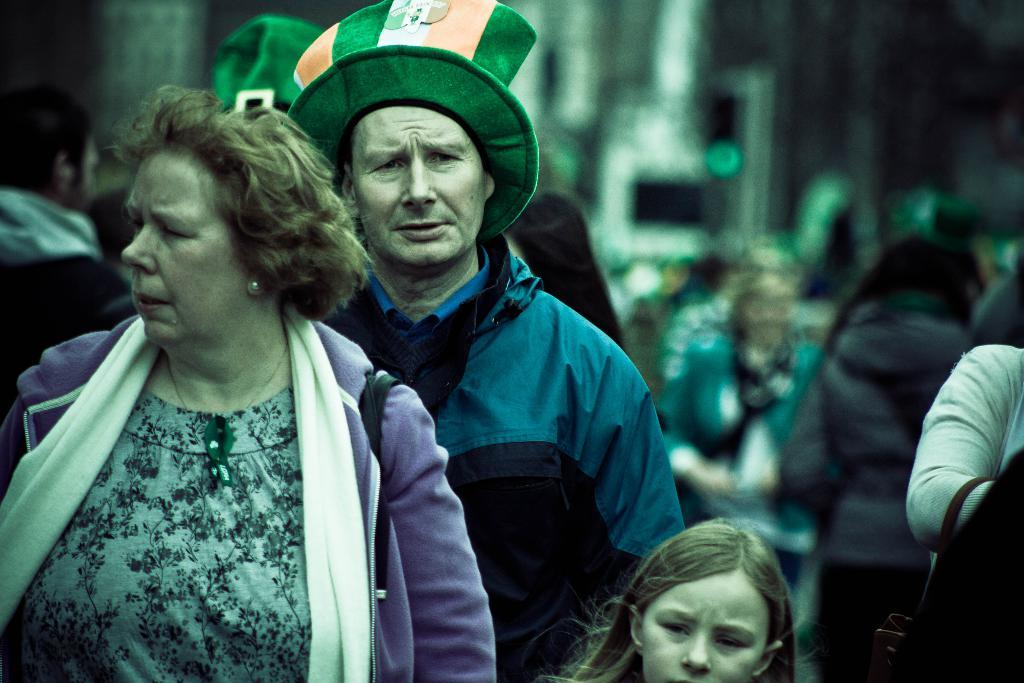What is happening in the image? There is a group of people in the image, and they are walking. Can you describe the background of the image? The background of the image is blurred. What type of education is being provided to the coal in the image? There is no coal present in the image, and therefore no education is being provided. 